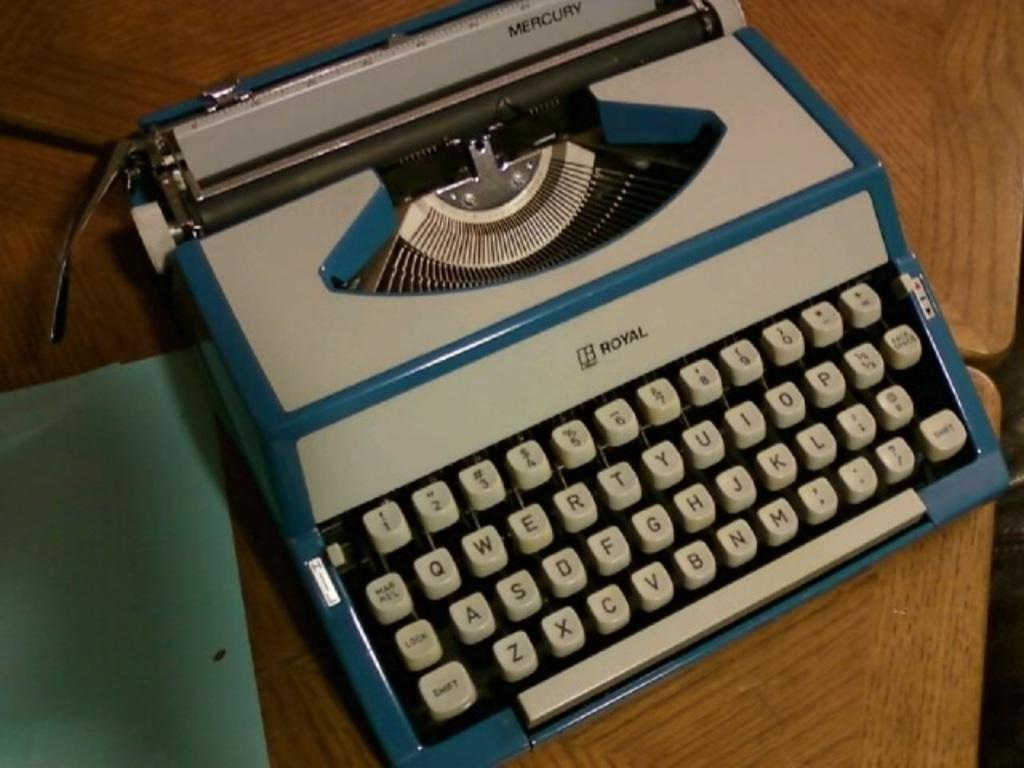What is the main object in the image? There is a typewriter machine in the image. What is the typewriter machine placed on? The typewriter machine is on a wooden surface. Can you describe any other objects or colors near the typewriter machine? There is a green color thing near the typewriter machine. How does the basketball act in the image? There is no basketball present in the image. What is the level of disgust shown by the typewriter machine in the image? Typewriter machines do not have the ability to express emotions like disgust. 